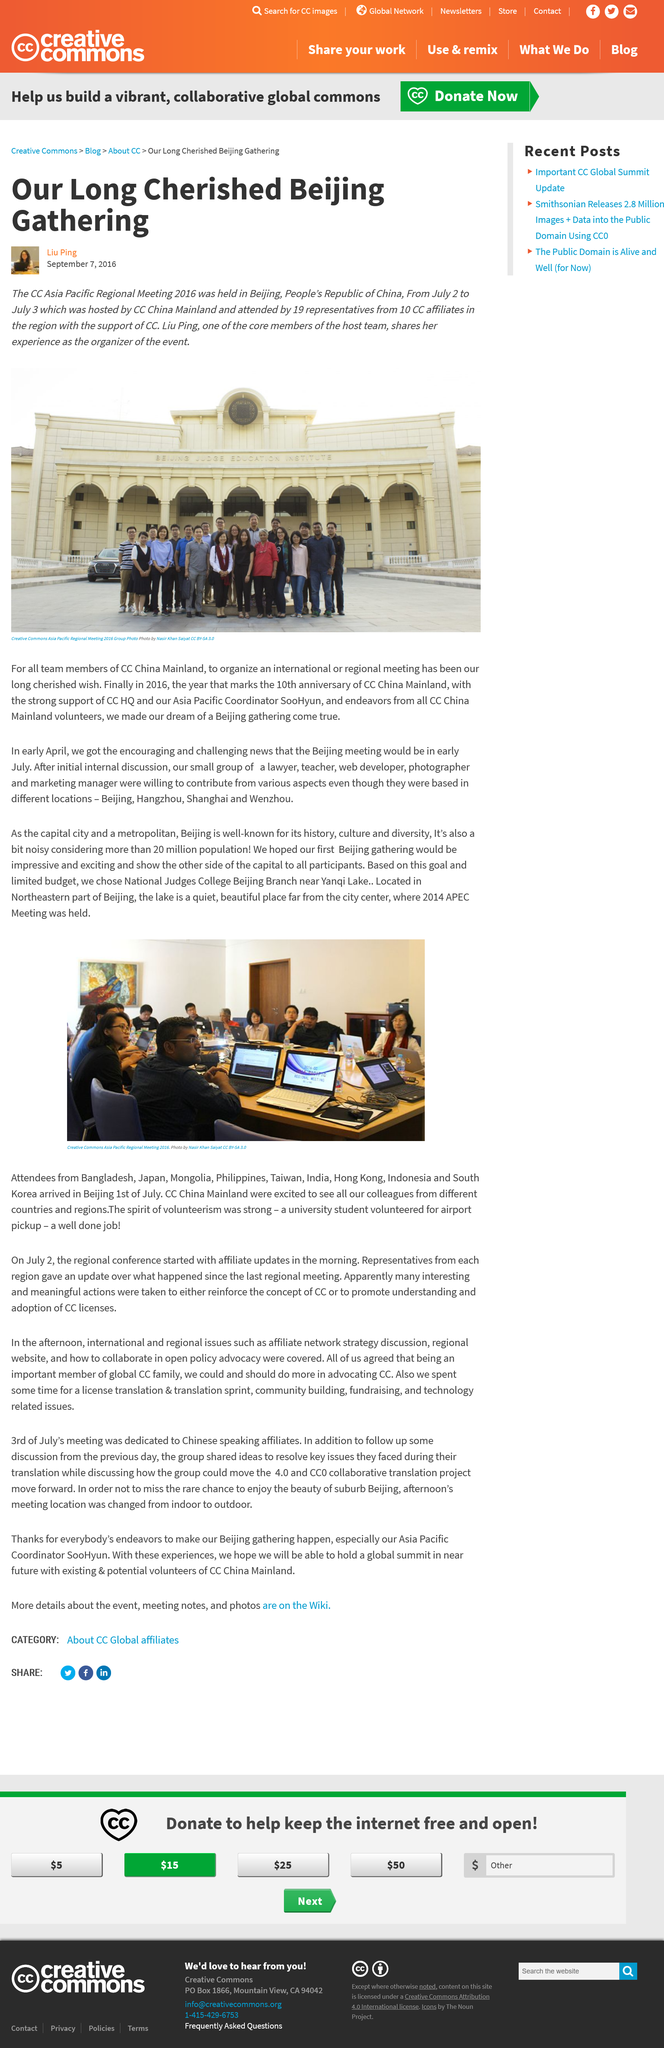Give some essential details in this illustration. In 2016, CC China Mainland celebrated its 10th anniversary. Out of the total number of representatives who attended the event, 19 representatives were present. The long-cherished wish of CC. Liu Ping, as described, was to organize an international or regional meeting. 